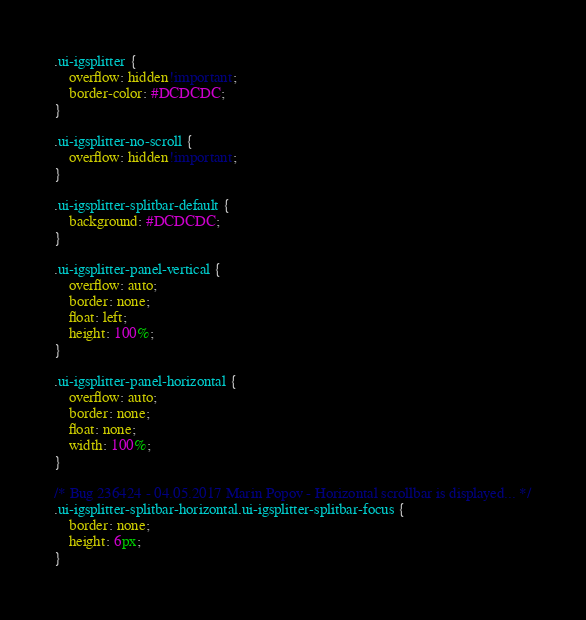Convert code to text. <code><loc_0><loc_0><loc_500><loc_500><_CSS_>.ui-igsplitter {
	overflow: hidden!important;
	border-color: #DCDCDC; 
}

.ui-igsplitter-no-scroll {
	overflow: hidden!important; 
}

.ui-igsplitter-splitbar-default {
	background: #DCDCDC; 
}

.ui-igsplitter-panel-vertical {
	overflow: auto;
	border: none;
	float: left;
	height: 100%;
}

.ui-igsplitter-panel-horizontal {
	overflow: auto;
	border: none;
	float: none;
	width: 100%;
}

/* Bug 236424 - 04.05.2017 Marin Popov - Horizontal scrollbar is displayed... */
.ui-igsplitter-splitbar-horizontal.ui-igsplitter-splitbar-focus {
    border: none;
    height: 6px;
}
</code> 